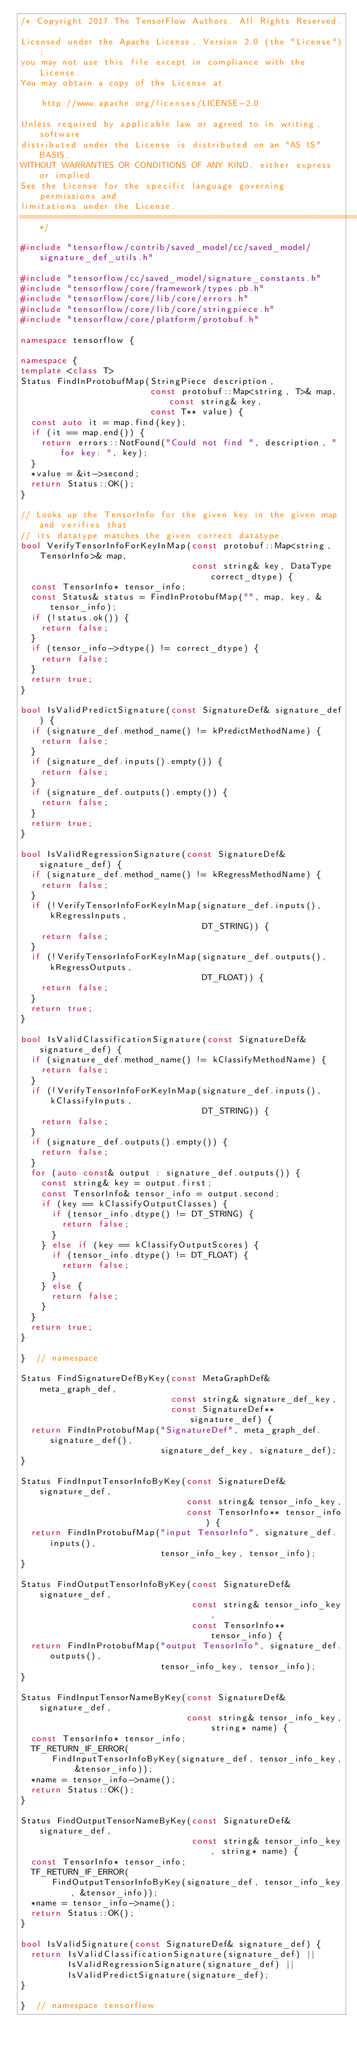<code> <loc_0><loc_0><loc_500><loc_500><_C++_>/* Copyright 2017 The TensorFlow Authors. All Rights Reserved.

Licensed under the Apache License, Version 2.0 (the "License");
you may not use this file except in compliance with the License.
You may obtain a copy of the License at

    http://www.apache.org/licenses/LICENSE-2.0

Unless required by applicable law or agreed to in writing, software
distributed under the License is distributed on an "AS IS" BASIS,
WITHOUT WARRANTIES OR CONDITIONS OF ANY KIND, either express or implied.
See the License for the specific language governing permissions and
limitations under the License.
==============================================================================*/

#include "tensorflow/contrib/saved_model/cc/saved_model/signature_def_utils.h"

#include "tensorflow/cc/saved_model/signature_constants.h"
#include "tensorflow/core/framework/types.pb.h"
#include "tensorflow/core/lib/core/errors.h"
#include "tensorflow/core/lib/core/stringpiece.h"
#include "tensorflow/core/platform/protobuf.h"

namespace tensorflow {

namespace {
template <class T>
Status FindInProtobufMap(StringPiece description,
                         const protobuf::Map<string, T>& map, const string& key,
                         const T** value) {
  const auto it = map.find(key);
  if (it == map.end()) {
    return errors::NotFound("Could not find ", description, " for key: ", key);
  }
  *value = &it->second;
  return Status::OK();
}

// Looks up the TensorInfo for the given key in the given map and verifies that
// its datatype matches the given correct datatype.
bool VerifyTensorInfoForKeyInMap(const protobuf::Map<string, TensorInfo>& map,
                                 const string& key, DataType correct_dtype) {
  const TensorInfo* tensor_info;
  const Status& status = FindInProtobufMap("", map, key, &tensor_info);
  if (!status.ok()) {
    return false;
  }
  if (tensor_info->dtype() != correct_dtype) {
    return false;
  }
  return true;
}

bool IsValidPredictSignature(const SignatureDef& signature_def) {
  if (signature_def.method_name() != kPredictMethodName) {
    return false;
  }
  if (signature_def.inputs().empty()) {
    return false;
  }
  if (signature_def.outputs().empty()) {
    return false;
  }
  return true;
}

bool IsValidRegressionSignature(const SignatureDef& signature_def) {
  if (signature_def.method_name() != kRegressMethodName) {
    return false;
  }
  if (!VerifyTensorInfoForKeyInMap(signature_def.inputs(), kRegressInputs,
                                   DT_STRING)) {
    return false;
  }
  if (!VerifyTensorInfoForKeyInMap(signature_def.outputs(), kRegressOutputs,
                                   DT_FLOAT)) {
    return false;
  }
  return true;
}

bool IsValidClassificationSignature(const SignatureDef& signature_def) {
  if (signature_def.method_name() != kClassifyMethodName) {
    return false;
  }
  if (!VerifyTensorInfoForKeyInMap(signature_def.inputs(), kClassifyInputs,
                                   DT_STRING)) {
    return false;
  }
  if (signature_def.outputs().empty()) {
    return false;
  }
  for (auto const& output : signature_def.outputs()) {
    const string& key = output.first;
    const TensorInfo& tensor_info = output.second;
    if (key == kClassifyOutputClasses) {
      if (tensor_info.dtype() != DT_STRING) {
        return false;
      }
    } else if (key == kClassifyOutputScores) {
      if (tensor_info.dtype() != DT_FLOAT) {
        return false;
      }
    } else {
      return false;
    }
  }
  return true;
}

}  // namespace

Status FindSignatureDefByKey(const MetaGraphDef& meta_graph_def,
                             const string& signature_def_key,
                             const SignatureDef** signature_def) {
  return FindInProtobufMap("SignatureDef", meta_graph_def.signature_def(),
                           signature_def_key, signature_def);
}

Status FindInputTensorInfoByKey(const SignatureDef& signature_def,
                                const string& tensor_info_key,
                                const TensorInfo** tensor_info) {
  return FindInProtobufMap("input TensorInfo", signature_def.inputs(),
                           tensor_info_key, tensor_info);
}

Status FindOutputTensorInfoByKey(const SignatureDef& signature_def,
                                 const string& tensor_info_key,
                                 const TensorInfo** tensor_info) {
  return FindInProtobufMap("output TensorInfo", signature_def.outputs(),
                           tensor_info_key, tensor_info);
}

Status FindInputTensorNameByKey(const SignatureDef& signature_def,
                                const string& tensor_info_key, string* name) {
  const TensorInfo* tensor_info;
  TF_RETURN_IF_ERROR(
      FindInputTensorInfoByKey(signature_def, tensor_info_key, &tensor_info));
  *name = tensor_info->name();
  return Status::OK();
}

Status FindOutputTensorNameByKey(const SignatureDef& signature_def,
                                 const string& tensor_info_key, string* name) {
  const TensorInfo* tensor_info;
  TF_RETURN_IF_ERROR(
      FindOutputTensorInfoByKey(signature_def, tensor_info_key, &tensor_info));
  *name = tensor_info->name();
  return Status::OK();
}

bool IsValidSignature(const SignatureDef& signature_def) {
  return IsValidClassificationSignature(signature_def) ||
         IsValidRegressionSignature(signature_def) ||
         IsValidPredictSignature(signature_def);
}

}  // namespace tensorflow
</code> 